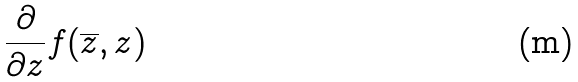<formula> <loc_0><loc_0><loc_500><loc_500>\frac { \partial } { \partial z } f ( \overline { z } , z )</formula> 